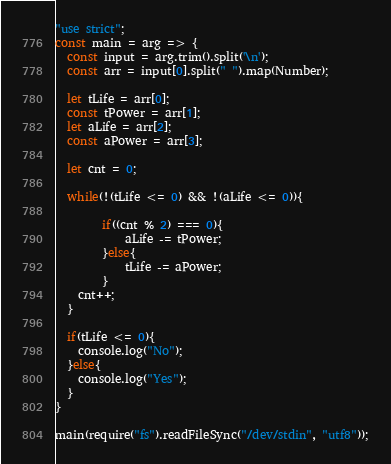Convert code to text. <code><loc_0><loc_0><loc_500><loc_500><_JavaScript_>"use strict";
const main = arg => {
  const input = arg.trim().split('\n');
  const arr = input[0].split(" ").map(Number);
  
  let tLife = arr[0];
  const tPower = arr[1];
  let aLife = arr[2];
  const aPower = arr[3];
  
  let cnt = 0;
  
  while(!(tLife <= 0) && !(aLife <= 0)){
        
        if((cnt % 2) === 0){
    		aLife -= tPower;
        }else{
          	tLife -= aPower;
        }
	cnt++;
  }
  
  if(tLife <= 0){
    console.log("No");
  }else{
    console.log("Yes");
  }
}
 
main(require("fs").readFileSync("/dev/stdin", "utf8"));</code> 